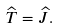Convert formula to latex. <formula><loc_0><loc_0><loc_500><loc_500>\widehat { T } = \widehat { J } .</formula> 